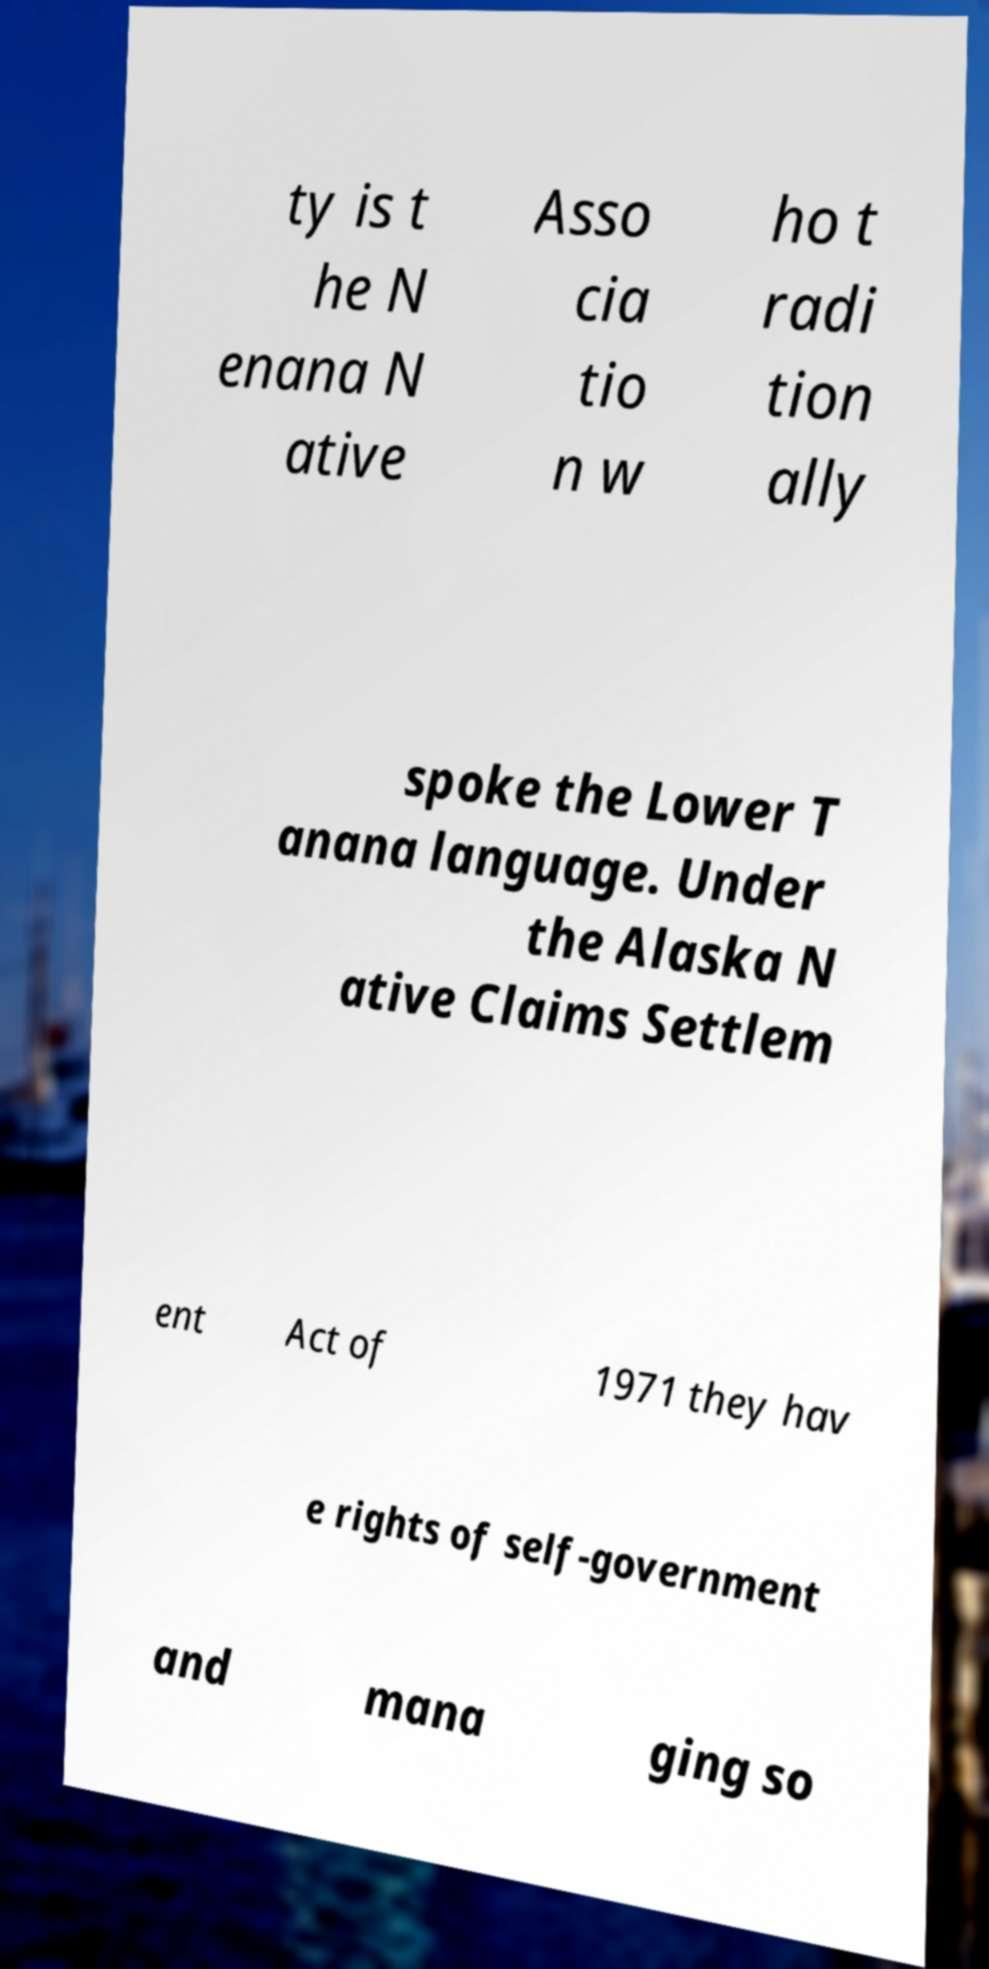Could you extract and type out the text from this image? ty is t he N enana N ative Asso cia tio n w ho t radi tion ally spoke the Lower T anana language. Under the Alaska N ative Claims Settlem ent Act of 1971 they hav e rights of self-government and mana ging so 